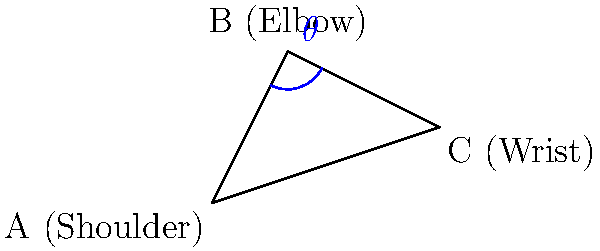In a golf swing analysis using stick figure representations, the shoulder (A), elbow (B), and wrist (C) form a triangle as shown in the figure. If the coordinates of these points are A(0,0), B(1,2), and C(3,1), what is the elbow angle $\theta$ in degrees? To find the elbow angle $\theta$, we need to follow these steps:

1. Calculate the vectors $\overrightarrow{BA}$ and $\overrightarrow{BC}$:
   $\overrightarrow{BA} = (0-1, 0-2) = (-1, -2)$
   $\overrightarrow{BC} = (3-1, 1-2) = (2, -1)$

2. Find the dot product of these vectors:
   $\overrightarrow{BA} \cdot \overrightarrow{BC} = (-1)(2) + (-2)(-1) = -2 + 2 = 0$

3. Calculate the magnitudes of the vectors:
   $|\overrightarrow{BA}| = \sqrt{(-1)^2 + (-2)^2} = \sqrt{5}$
   $|\overrightarrow{BC}| = \sqrt{2^2 + (-1)^2} = \sqrt{5}$

4. Use the dot product formula to find $\cos \theta$:
   $\cos \theta = \frac{\overrightarrow{BA} \cdot \overrightarrow{BC}}{|\overrightarrow{BA}||\overrightarrow{BC}|} = \frac{0}{\sqrt{5}\sqrt{5}} = 0$

5. Take the inverse cosine (arccos) to find $\theta$:
   $\theta = \arccos(0) = 90°$

Therefore, the elbow angle $\theta$ is 90 degrees.
Answer: 90° 